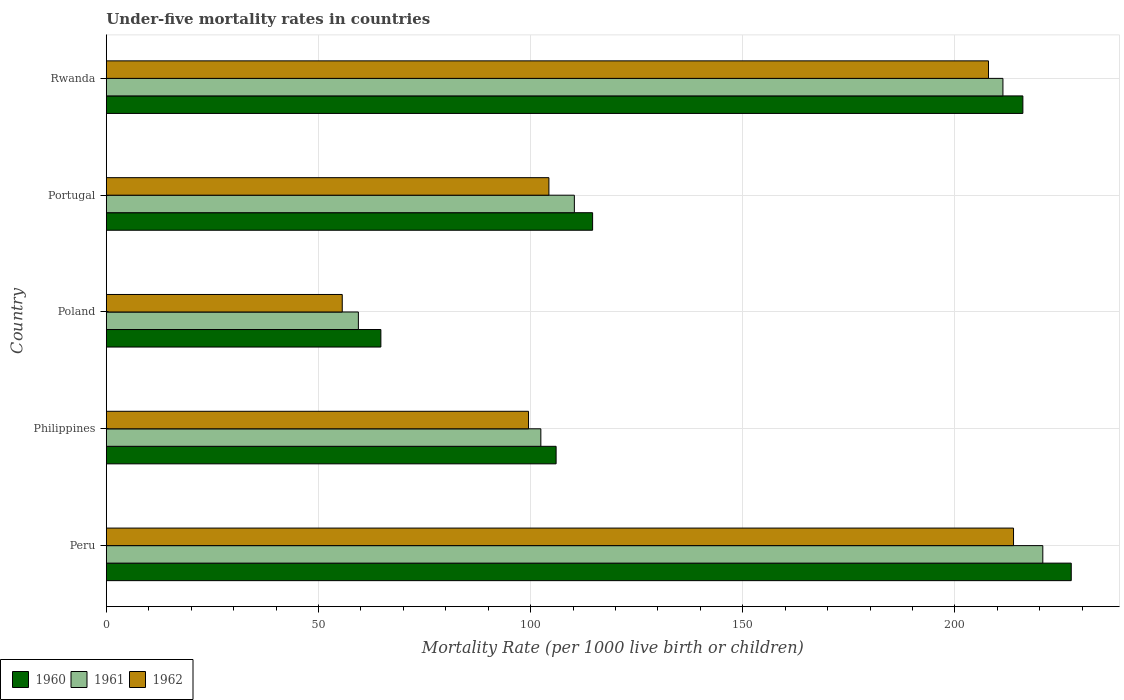How many groups of bars are there?
Ensure brevity in your answer.  5. Are the number of bars per tick equal to the number of legend labels?
Your answer should be compact. Yes. How many bars are there on the 4th tick from the bottom?
Provide a short and direct response. 3. In how many cases, is the number of bars for a given country not equal to the number of legend labels?
Provide a short and direct response. 0. What is the under-five mortality rate in 1960 in Portugal?
Your answer should be very brief. 114.6. Across all countries, what is the maximum under-five mortality rate in 1960?
Make the answer very short. 227.4. Across all countries, what is the minimum under-five mortality rate in 1961?
Offer a terse response. 59.4. In which country was the under-five mortality rate in 1960 minimum?
Your answer should be very brief. Poland. What is the total under-five mortality rate in 1960 in the graph?
Keep it short and to the point. 728.7. What is the difference between the under-five mortality rate in 1961 in Poland and that in Portugal?
Your response must be concise. -50.9. What is the difference between the under-five mortality rate in 1962 in Rwanda and the under-five mortality rate in 1960 in Philippines?
Provide a succinct answer. 101.9. What is the average under-five mortality rate in 1962 per country?
Ensure brevity in your answer.  136.22. What is the difference between the under-five mortality rate in 1962 and under-five mortality rate in 1961 in Poland?
Keep it short and to the point. -3.8. In how many countries, is the under-five mortality rate in 1962 greater than 30 ?
Offer a very short reply. 5. What is the ratio of the under-five mortality rate in 1962 in Philippines to that in Rwanda?
Your answer should be compact. 0.48. What is the difference between the highest and the second highest under-five mortality rate in 1962?
Your response must be concise. 5.9. What is the difference between the highest and the lowest under-five mortality rate in 1961?
Provide a short and direct response. 161.3. Is the sum of the under-five mortality rate in 1961 in Portugal and Rwanda greater than the maximum under-five mortality rate in 1962 across all countries?
Provide a short and direct response. Yes. What does the 2nd bar from the top in Poland represents?
Provide a short and direct response. 1961. Is it the case that in every country, the sum of the under-five mortality rate in 1961 and under-five mortality rate in 1960 is greater than the under-five mortality rate in 1962?
Provide a succinct answer. Yes. How many bars are there?
Provide a succinct answer. 15. How many countries are there in the graph?
Ensure brevity in your answer.  5. What is the difference between two consecutive major ticks on the X-axis?
Make the answer very short. 50. Does the graph contain any zero values?
Provide a succinct answer. No. Does the graph contain grids?
Your answer should be very brief. Yes. What is the title of the graph?
Provide a succinct answer. Under-five mortality rates in countries. Does "1968" appear as one of the legend labels in the graph?
Your answer should be very brief. No. What is the label or title of the X-axis?
Provide a succinct answer. Mortality Rate (per 1000 live birth or children). What is the Mortality Rate (per 1000 live birth or children) of 1960 in Peru?
Offer a terse response. 227.4. What is the Mortality Rate (per 1000 live birth or children) of 1961 in Peru?
Your response must be concise. 220.7. What is the Mortality Rate (per 1000 live birth or children) in 1962 in Peru?
Offer a terse response. 213.8. What is the Mortality Rate (per 1000 live birth or children) of 1960 in Philippines?
Your answer should be compact. 106. What is the Mortality Rate (per 1000 live birth or children) in 1961 in Philippines?
Give a very brief answer. 102.4. What is the Mortality Rate (per 1000 live birth or children) of 1962 in Philippines?
Give a very brief answer. 99.5. What is the Mortality Rate (per 1000 live birth or children) in 1960 in Poland?
Offer a very short reply. 64.7. What is the Mortality Rate (per 1000 live birth or children) of 1961 in Poland?
Make the answer very short. 59.4. What is the Mortality Rate (per 1000 live birth or children) of 1962 in Poland?
Offer a terse response. 55.6. What is the Mortality Rate (per 1000 live birth or children) in 1960 in Portugal?
Provide a short and direct response. 114.6. What is the Mortality Rate (per 1000 live birth or children) in 1961 in Portugal?
Provide a succinct answer. 110.3. What is the Mortality Rate (per 1000 live birth or children) in 1962 in Portugal?
Provide a short and direct response. 104.3. What is the Mortality Rate (per 1000 live birth or children) in 1960 in Rwanda?
Provide a succinct answer. 216. What is the Mortality Rate (per 1000 live birth or children) in 1961 in Rwanda?
Your answer should be very brief. 211.3. What is the Mortality Rate (per 1000 live birth or children) of 1962 in Rwanda?
Provide a short and direct response. 207.9. Across all countries, what is the maximum Mortality Rate (per 1000 live birth or children) of 1960?
Make the answer very short. 227.4. Across all countries, what is the maximum Mortality Rate (per 1000 live birth or children) in 1961?
Provide a short and direct response. 220.7. Across all countries, what is the maximum Mortality Rate (per 1000 live birth or children) in 1962?
Your answer should be very brief. 213.8. Across all countries, what is the minimum Mortality Rate (per 1000 live birth or children) of 1960?
Provide a short and direct response. 64.7. Across all countries, what is the minimum Mortality Rate (per 1000 live birth or children) in 1961?
Ensure brevity in your answer.  59.4. Across all countries, what is the minimum Mortality Rate (per 1000 live birth or children) of 1962?
Your answer should be very brief. 55.6. What is the total Mortality Rate (per 1000 live birth or children) of 1960 in the graph?
Ensure brevity in your answer.  728.7. What is the total Mortality Rate (per 1000 live birth or children) in 1961 in the graph?
Provide a short and direct response. 704.1. What is the total Mortality Rate (per 1000 live birth or children) of 1962 in the graph?
Keep it short and to the point. 681.1. What is the difference between the Mortality Rate (per 1000 live birth or children) in 1960 in Peru and that in Philippines?
Your answer should be very brief. 121.4. What is the difference between the Mortality Rate (per 1000 live birth or children) of 1961 in Peru and that in Philippines?
Your response must be concise. 118.3. What is the difference between the Mortality Rate (per 1000 live birth or children) of 1962 in Peru and that in Philippines?
Offer a terse response. 114.3. What is the difference between the Mortality Rate (per 1000 live birth or children) of 1960 in Peru and that in Poland?
Keep it short and to the point. 162.7. What is the difference between the Mortality Rate (per 1000 live birth or children) in 1961 in Peru and that in Poland?
Your answer should be compact. 161.3. What is the difference between the Mortality Rate (per 1000 live birth or children) of 1962 in Peru and that in Poland?
Ensure brevity in your answer.  158.2. What is the difference between the Mortality Rate (per 1000 live birth or children) in 1960 in Peru and that in Portugal?
Offer a very short reply. 112.8. What is the difference between the Mortality Rate (per 1000 live birth or children) of 1961 in Peru and that in Portugal?
Ensure brevity in your answer.  110.4. What is the difference between the Mortality Rate (per 1000 live birth or children) of 1962 in Peru and that in Portugal?
Offer a terse response. 109.5. What is the difference between the Mortality Rate (per 1000 live birth or children) of 1960 in Peru and that in Rwanda?
Offer a terse response. 11.4. What is the difference between the Mortality Rate (per 1000 live birth or children) in 1960 in Philippines and that in Poland?
Provide a short and direct response. 41.3. What is the difference between the Mortality Rate (per 1000 live birth or children) in 1961 in Philippines and that in Poland?
Give a very brief answer. 43. What is the difference between the Mortality Rate (per 1000 live birth or children) in 1962 in Philippines and that in Poland?
Your response must be concise. 43.9. What is the difference between the Mortality Rate (per 1000 live birth or children) in 1960 in Philippines and that in Rwanda?
Your answer should be very brief. -110. What is the difference between the Mortality Rate (per 1000 live birth or children) of 1961 in Philippines and that in Rwanda?
Offer a terse response. -108.9. What is the difference between the Mortality Rate (per 1000 live birth or children) in 1962 in Philippines and that in Rwanda?
Offer a terse response. -108.4. What is the difference between the Mortality Rate (per 1000 live birth or children) of 1960 in Poland and that in Portugal?
Ensure brevity in your answer.  -49.9. What is the difference between the Mortality Rate (per 1000 live birth or children) of 1961 in Poland and that in Portugal?
Ensure brevity in your answer.  -50.9. What is the difference between the Mortality Rate (per 1000 live birth or children) in 1962 in Poland and that in Portugal?
Your answer should be very brief. -48.7. What is the difference between the Mortality Rate (per 1000 live birth or children) of 1960 in Poland and that in Rwanda?
Offer a terse response. -151.3. What is the difference between the Mortality Rate (per 1000 live birth or children) in 1961 in Poland and that in Rwanda?
Keep it short and to the point. -151.9. What is the difference between the Mortality Rate (per 1000 live birth or children) of 1962 in Poland and that in Rwanda?
Make the answer very short. -152.3. What is the difference between the Mortality Rate (per 1000 live birth or children) of 1960 in Portugal and that in Rwanda?
Make the answer very short. -101.4. What is the difference between the Mortality Rate (per 1000 live birth or children) of 1961 in Portugal and that in Rwanda?
Make the answer very short. -101. What is the difference between the Mortality Rate (per 1000 live birth or children) of 1962 in Portugal and that in Rwanda?
Provide a short and direct response. -103.6. What is the difference between the Mortality Rate (per 1000 live birth or children) of 1960 in Peru and the Mortality Rate (per 1000 live birth or children) of 1961 in Philippines?
Keep it short and to the point. 125. What is the difference between the Mortality Rate (per 1000 live birth or children) in 1960 in Peru and the Mortality Rate (per 1000 live birth or children) in 1962 in Philippines?
Provide a short and direct response. 127.9. What is the difference between the Mortality Rate (per 1000 live birth or children) of 1961 in Peru and the Mortality Rate (per 1000 live birth or children) of 1962 in Philippines?
Give a very brief answer. 121.2. What is the difference between the Mortality Rate (per 1000 live birth or children) of 1960 in Peru and the Mortality Rate (per 1000 live birth or children) of 1961 in Poland?
Give a very brief answer. 168. What is the difference between the Mortality Rate (per 1000 live birth or children) of 1960 in Peru and the Mortality Rate (per 1000 live birth or children) of 1962 in Poland?
Your response must be concise. 171.8. What is the difference between the Mortality Rate (per 1000 live birth or children) in 1961 in Peru and the Mortality Rate (per 1000 live birth or children) in 1962 in Poland?
Offer a terse response. 165.1. What is the difference between the Mortality Rate (per 1000 live birth or children) in 1960 in Peru and the Mortality Rate (per 1000 live birth or children) in 1961 in Portugal?
Offer a terse response. 117.1. What is the difference between the Mortality Rate (per 1000 live birth or children) in 1960 in Peru and the Mortality Rate (per 1000 live birth or children) in 1962 in Portugal?
Offer a very short reply. 123.1. What is the difference between the Mortality Rate (per 1000 live birth or children) in 1961 in Peru and the Mortality Rate (per 1000 live birth or children) in 1962 in Portugal?
Provide a short and direct response. 116.4. What is the difference between the Mortality Rate (per 1000 live birth or children) in 1961 in Peru and the Mortality Rate (per 1000 live birth or children) in 1962 in Rwanda?
Make the answer very short. 12.8. What is the difference between the Mortality Rate (per 1000 live birth or children) of 1960 in Philippines and the Mortality Rate (per 1000 live birth or children) of 1961 in Poland?
Offer a terse response. 46.6. What is the difference between the Mortality Rate (per 1000 live birth or children) of 1960 in Philippines and the Mortality Rate (per 1000 live birth or children) of 1962 in Poland?
Ensure brevity in your answer.  50.4. What is the difference between the Mortality Rate (per 1000 live birth or children) of 1961 in Philippines and the Mortality Rate (per 1000 live birth or children) of 1962 in Poland?
Ensure brevity in your answer.  46.8. What is the difference between the Mortality Rate (per 1000 live birth or children) in 1960 in Philippines and the Mortality Rate (per 1000 live birth or children) in 1961 in Portugal?
Your answer should be very brief. -4.3. What is the difference between the Mortality Rate (per 1000 live birth or children) of 1960 in Philippines and the Mortality Rate (per 1000 live birth or children) of 1961 in Rwanda?
Provide a short and direct response. -105.3. What is the difference between the Mortality Rate (per 1000 live birth or children) in 1960 in Philippines and the Mortality Rate (per 1000 live birth or children) in 1962 in Rwanda?
Your answer should be compact. -101.9. What is the difference between the Mortality Rate (per 1000 live birth or children) of 1961 in Philippines and the Mortality Rate (per 1000 live birth or children) of 1962 in Rwanda?
Ensure brevity in your answer.  -105.5. What is the difference between the Mortality Rate (per 1000 live birth or children) in 1960 in Poland and the Mortality Rate (per 1000 live birth or children) in 1961 in Portugal?
Provide a succinct answer. -45.6. What is the difference between the Mortality Rate (per 1000 live birth or children) of 1960 in Poland and the Mortality Rate (per 1000 live birth or children) of 1962 in Portugal?
Keep it short and to the point. -39.6. What is the difference between the Mortality Rate (per 1000 live birth or children) in 1961 in Poland and the Mortality Rate (per 1000 live birth or children) in 1962 in Portugal?
Your response must be concise. -44.9. What is the difference between the Mortality Rate (per 1000 live birth or children) in 1960 in Poland and the Mortality Rate (per 1000 live birth or children) in 1961 in Rwanda?
Give a very brief answer. -146.6. What is the difference between the Mortality Rate (per 1000 live birth or children) in 1960 in Poland and the Mortality Rate (per 1000 live birth or children) in 1962 in Rwanda?
Offer a very short reply. -143.2. What is the difference between the Mortality Rate (per 1000 live birth or children) in 1961 in Poland and the Mortality Rate (per 1000 live birth or children) in 1962 in Rwanda?
Offer a terse response. -148.5. What is the difference between the Mortality Rate (per 1000 live birth or children) of 1960 in Portugal and the Mortality Rate (per 1000 live birth or children) of 1961 in Rwanda?
Keep it short and to the point. -96.7. What is the difference between the Mortality Rate (per 1000 live birth or children) in 1960 in Portugal and the Mortality Rate (per 1000 live birth or children) in 1962 in Rwanda?
Offer a terse response. -93.3. What is the difference between the Mortality Rate (per 1000 live birth or children) of 1961 in Portugal and the Mortality Rate (per 1000 live birth or children) of 1962 in Rwanda?
Your answer should be very brief. -97.6. What is the average Mortality Rate (per 1000 live birth or children) in 1960 per country?
Your answer should be very brief. 145.74. What is the average Mortality Rate (per 1000 live birth or children) in 1961 per country?
Make the answer very short. 140.82. What is the average Mortality Rate (per 1000 live birth or children) of 1962 per country?
Give a very brief answer. 136.22. What is the difference between the Mortality Rate (per 1000 live birth or children) of 1960 and Mortality Rate (per 1000 live birth or children) of 1962 in Peru?
Give a very brief answer. 13.6. What is the difference between the Mortality Rate (per 1000 live birth or children) in 1960 and Mortality Rate (per 1000 live birth or children) in 1962 in Philippines?
Your response must be concise. 6.5. What is the difference between the Mortality Rate (per 1000 live birth or children) of 1961 and Mortality Rate (per 1000 live birth or children) of 1962 in Philippines?
Your answer should be compact. 2.9. What is the difference between the Mortality Rate (per 1000 live birth or children) in 1960 and Mortality Rate (per 1000 live birth or children) in 1961 in Poland?
Make the answer very short. 5.3. What is the difference between the Mortality Rate (per 1000 live birth or children) of 1960 and Mortality Rate (per 1000 live birth or children) of 1962 in Portugal?
Your answer should be compact. 10.3. What is the difference between the Mortality Rate (per 1000 live birth or children) of 1961 and Mortality Rate (per 1000 live birth or children) of 1962 in Rwanda?
Your answer should be very brief. 3.4. What is the ratio of the Mortality Rate (per 1000 live birth or children) of 1960 in Peru to that in Philippines?
Offer a very short reply. 2.15. What is the ratio of the Mortality Rate (per 1000 live birth or children) in 1961 in Peru to that in Philippines?
Make the answer very short. 2.16. What is the ratio of the Mortality Rate (per 1000 live birth or children) in 1962 in Peru to that in Philippines?
Your response must be concise. 2.15. What is the ratio of the Mortality Rate (per 1000 live birth or children) of 1960 in Peru to that in Poland?
Offer a terse response. 3.51. What is the ratio of the Mortality Rate (per 1000 live birth or children) in 1961 in Peru to that in Poland?
Provide a short and direct response. 3.72. What is the ratio of the Mortality Rate (per 1000 live birth or children) in 1962 in Peru to that in Poland?
Give a very brief answer. 3.85. What is the ratio of the Mortality Rate (per 1000 live birth or children) in 1960 in Peru to that in Portugal?
Your answer should be compact. 1.98. What is the ratio of the Mortality Rate (per 1000 live birth or children) in 1961 in Peru to that in Portugal?
Make the answer very short. 2. What is the ratio of the Mortality Rate (per 1000 live birth or children) in 1962 in Peru to that in Portugal?
Provide a short and direct response. 2.05. What is the ratio of the Mortality Rate (per 1000 live birth or children) of 1960 in Peru to that in Rwanda?
Your answer should be compact. 1.05. What is the ratio of the Mortality Rate (per 1000 live birth or children) in 1961 in Peru to that in Rwanda?
Keep it short and to the point. 1.04. What is the ratio of the Mortality Rate (per 1000 live birth or children) of 1962 in Peru to that in Rwanda?
Offer a terse response. 1.03. What is the ratio of the Mortality Rate (per 1000 live birth or children) of 1960 in Philippines to that in Poland?
Your answer should be compact. 1.64. What is the ratio of the Mortality Rate (per 1000 live birth or children) in 1961 in Philippines to that in Poland?
Your answer should be compact. 1.72. What is the ratio of the Mortality Rate (per 1000 live birth or children) in 1962 in Philippines to that in Poland?
Provide a succinct answer. 1.79. What is the ratio of the Mortality Rate (per 1000 live birth or children) of 1960 in Philippines to that in Portugal?
Provide a succinct answer. 0.93. What is the ratio of the Mortality Rate (per 1000 live birth or children) of 1961 in Philippines to that in Portugal?
Keep it short and to the point. 0.93. What is the ratio of the Mortality Rate (per 1000 live birth or children) in 1962 in Philippines to that in Portugal?
Give a very brief answer. 0.95. What is the ratio of the Mortality Rate (per 1000 live birth or children) in 1960 in Philippines to that in Rwanda?
Provide a succinct answer. 0.49. What is the ratio of the Mortality Rate (per 1000 live birth or children) of 1961 in Philippines to that in Rwanda?
Your response must be concise. 0.48. What is the ratio of the Mortality Rate (per 1000 live birth or children) in 1962 in Philippines to that in Rwanda?
Provide a short and direct response. 0.48. What is the ratio of the Mortality Rate (per 1000 live birth or children) in 1960 in Poland to that in Portugal?
Provide a short and direct response. 0.56. What is the ratio of the Mortality Rate (per 1000 live birth or children) in 1961 in Poland to that in Portugal?
Make the answer very short. 0.54. What is the ratio of the Mortality Rate (per 1000 live birth or children) in 1962 in Poland to that in Portugal?
Give a very brief answer. 0.53. What is the ratio of the Mortality Rate (per 1000 live birth or children) of 1960 in Poland to that in Rwanda?
Give a very brief answer. 0.3. What is the ratio of the Mortality Rate (per 1000 live birth or children) of 1961 in Poland to that in Rwanda?
Provide a succinct answer. 0.28. What is the ratio of the Mortality Rate (per 1000 live birth or children) of 1962 in Poland to that in Rwanda?
Keep it short and to the point. 0.27. What is the ratio of the Mortality Rate (per 1000 live birth or children) in 1960 in Portugal to that in Rwanda?
Your response must be concise. 0.53. What is the ratio of the Mortality Rate (per 1000 live birth or children) of 1961 in Portugal to that in Rwanda?
Ensure brevity in your answer.  0.52. What is the ratio of the Mortality Rate (per 1000 live birth or children) in 1962 in Portugal to that in Rwanda?
Give a very brief answer. 0.5. What is the difference between the highest and the lowest Mortality Rate (per 1000 live birth or children) in 1960?
Provide a short and direct response. 162.7. What is the difference between the highest and the lowest Mortality Rate (per 1000 live birth or children) in 1961?
Your response must be concise. 161.3. What is the difference between the highest and the lowest Mortality Rate (per 1000 live birth or children) in 1962?
Provide a succinct answer. 158.2. 